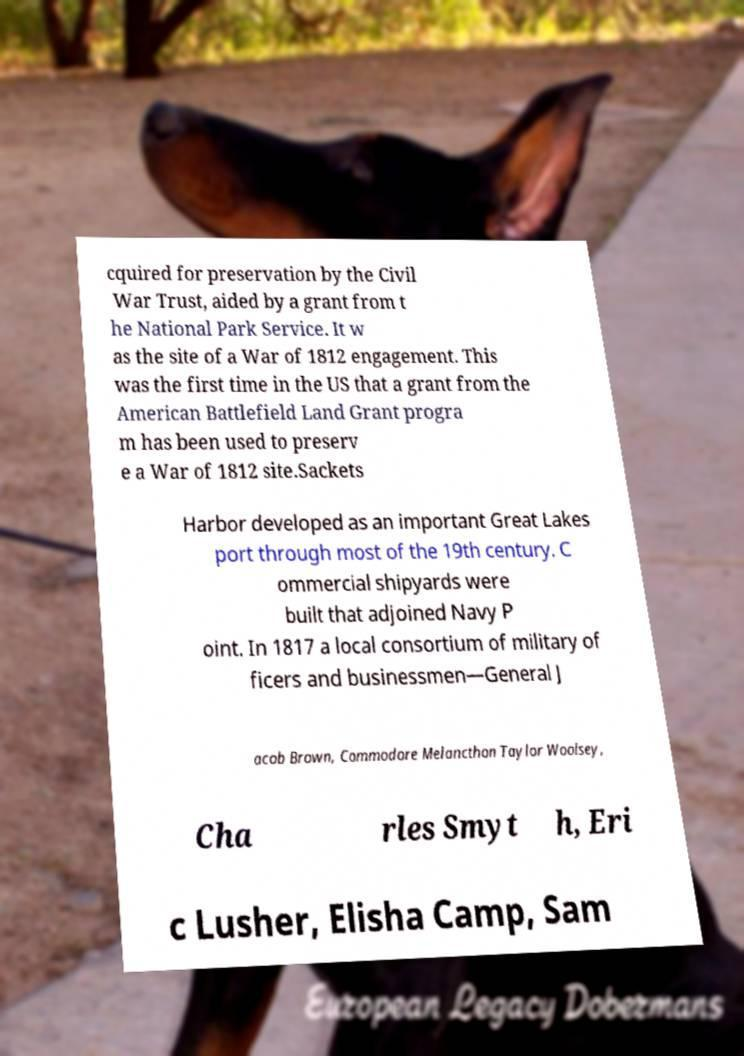Please identify and transcribe the text found in this image. cquired for preservation by the Civil War Trust, aided by a grant from t he National Park Service. It w as the site of a War of 1812 engagement. This was the first time in the US that a grant from the American Battlefield Land Grant progra m has been used to preserv e a War of 1812 site.Sackets Harbor developed as an important Great Lakes port through most of the 19th century. C ommercial shipyards were built that adjoined Navy P oint. In 1817 a local consortium of military of ficers and businessmen—General J acob Brown, Commodore Melancthon Taylor Woolsey, Cha rles Smyt h, Eri c Lusher, Elisha Camp, Sam 